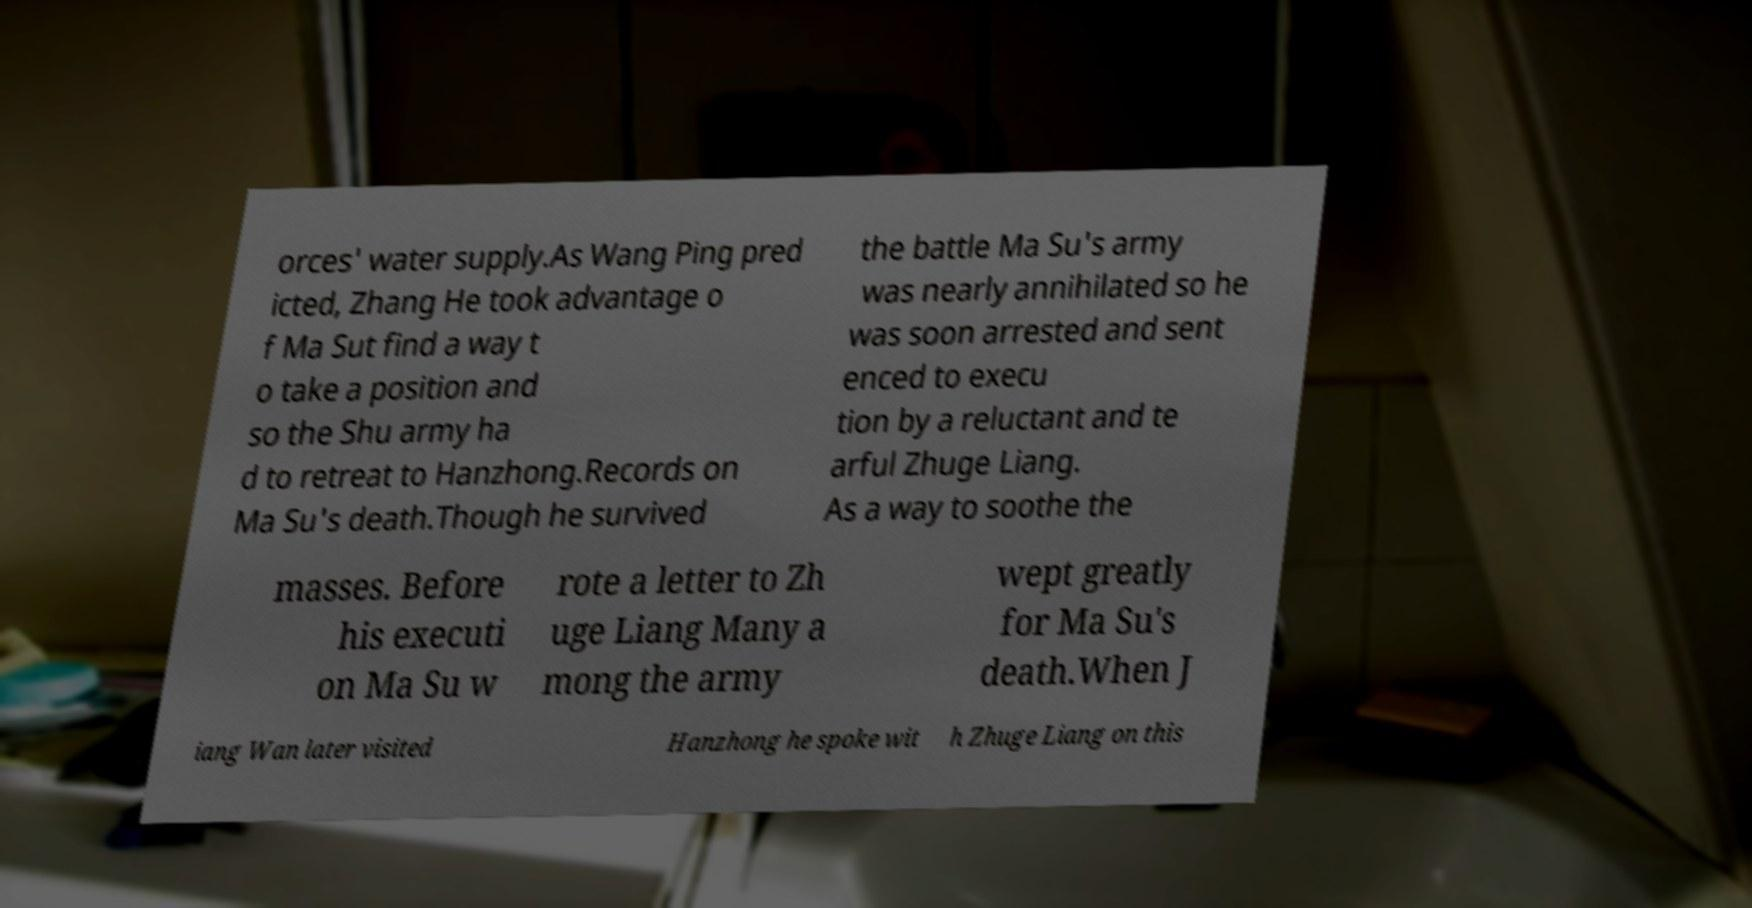Could you extract and type out the text from this image? orces' water supply.As Wang Ping pred icted, Zhang He took advantage o f Ma Sut find a way t o take a position and so the Shu army ha d to retreat to Hanzhong.Records on Ma Su's death.Though he survived the battle Ma Su's army was nearly annihilated so he was soon arrested and sent enced to execu tion by a reluctant and te arful Zhuge Liang. As a way to soothe the masses. Before his executi on Ma Su w rote a letter to Zh uge Liang Many a mong the army wept greatly for Ma Su's death.When J iang Wan later visited Hanzhong he spoke wit h Zhuge Liang on this 